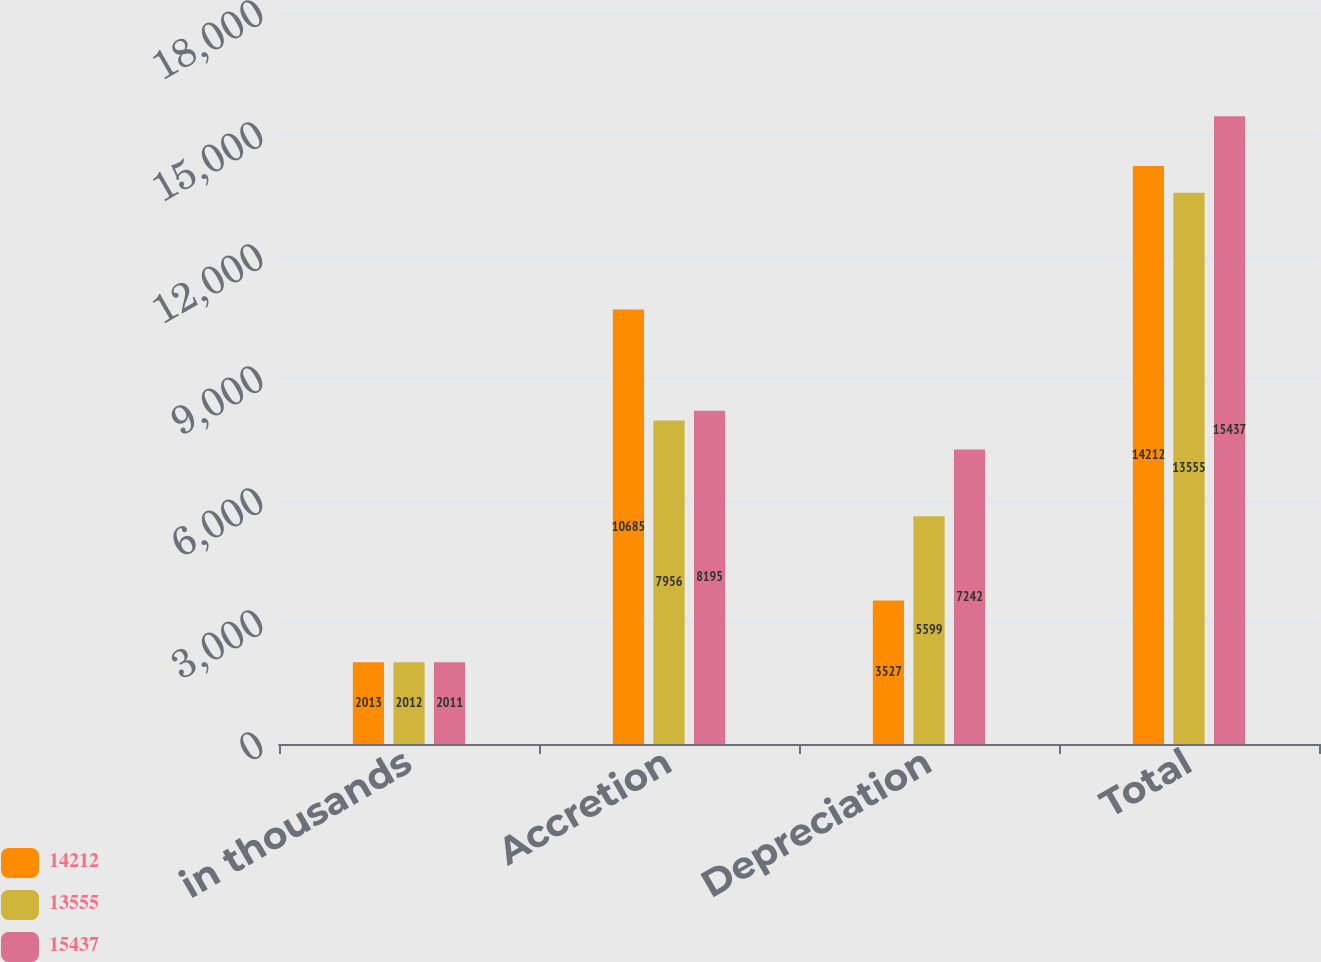Convert chart to OTSL. <chart><loc_0><loc_0><loc_500><loc_500><stacked_bar_chart><ecel><fcel>in thousands<fcel>Accretion<fcel>Depreciation<fcel>Total<nl><fcel>14212<fcel>2013<fcel>10685<fcel>3527<fcel>14212<nl><fcel>13555<fcel>2012<fcel>7956<fcel>5599<fcel>13555<nl><fcel>15437<fcel>2011<fcel>8195<fcel>7242<fcel>15437<nl></chart> 